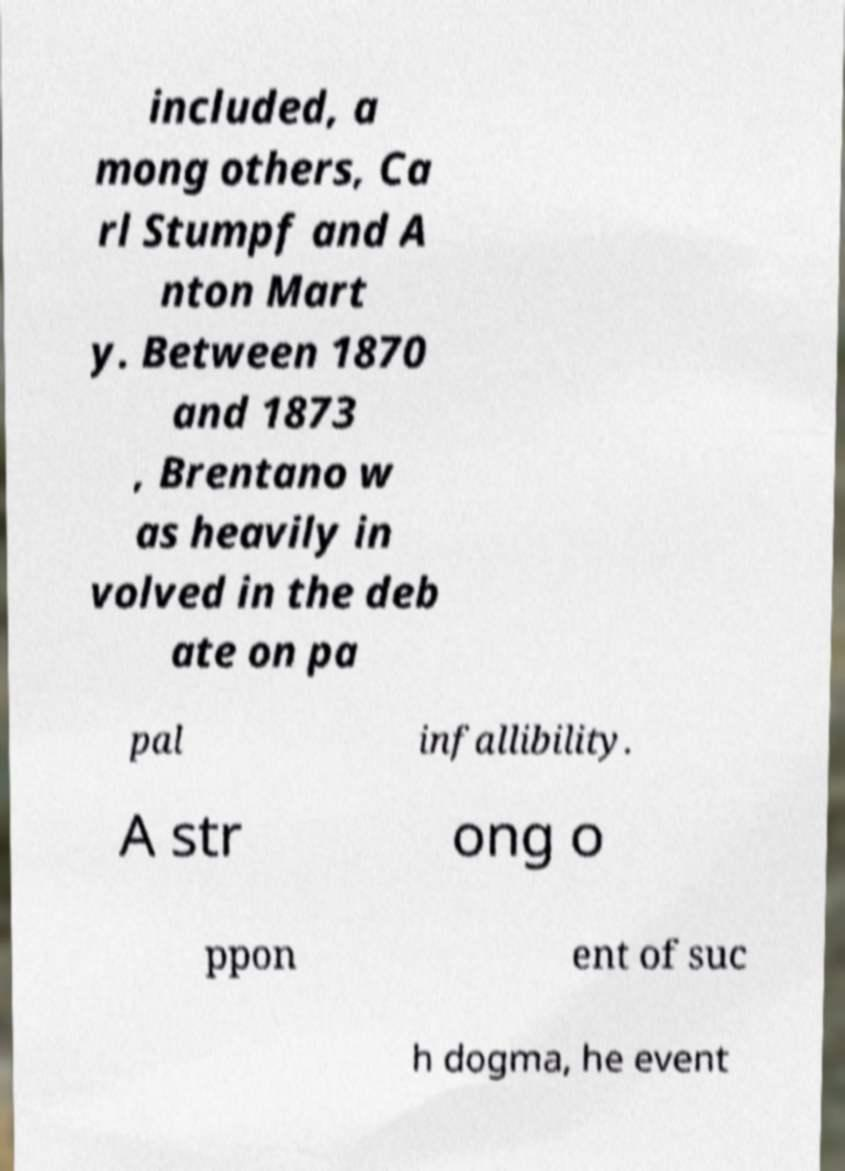What messages or text are displayed in this image? I need them in a readable, typed format. included, a mong others, Ca rl Stumpf and A nton Mart y. Between 1870 and 1873 , Brentano w as heavily in volved in the deb ate on pa pal infallibility. A str ong o ppon ent of suc h dogma, he event 